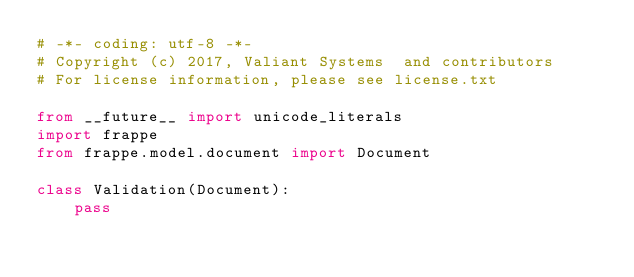Convert code to text. <code><loc_0><loc_0><loc_500><loc_500><_Python_># -*- coding: utf-8 -*-
# Copyright (c) 2017, Valiant Systems  and contributors
# For license information, please see license.txt

from __future__ import unicode_literals
import frappe
from frappe.model.document import Document

class Validation(Document):
	pass
</code> 